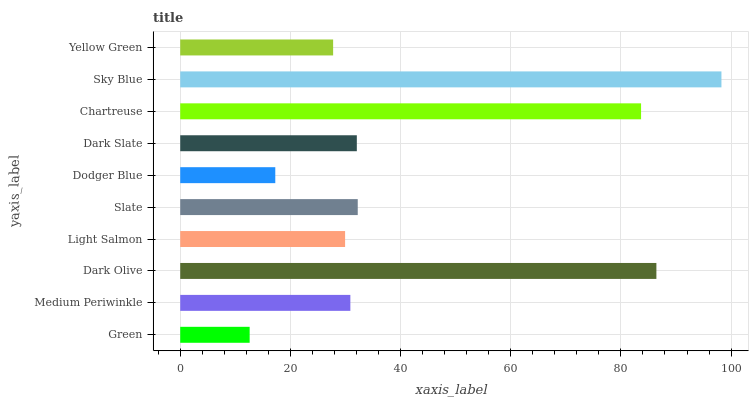Is Green the minimum?
Answer yes or no. Yes. Is Sky Blue the maximum?
Answer yes or no. Yes. Is Medium Periwinkle the minimum?
Answer yes or no. No. Is Medium Periwinkle the maximum?
Answer yes or no. No. Is Medium Periwinkle greater than Green?
Answer yes or no. Yes. Is Green less than Medium Periwinkle?
Answer yes or no. Yes. Is Green greater than Medium Periwinkle?
Answer yes or no. No. Is Medium Periwinkle less than Green?
Answer yes or no. No. Is Dark Slate the high median?
Answer yes or no. Yes. Is Medium Periwinkle the low median?
Answer yes or no. Yes. Is Yellow Green the high median?
Answer yes or no. No. Is Green the low median?
Answer yes or no. No. 